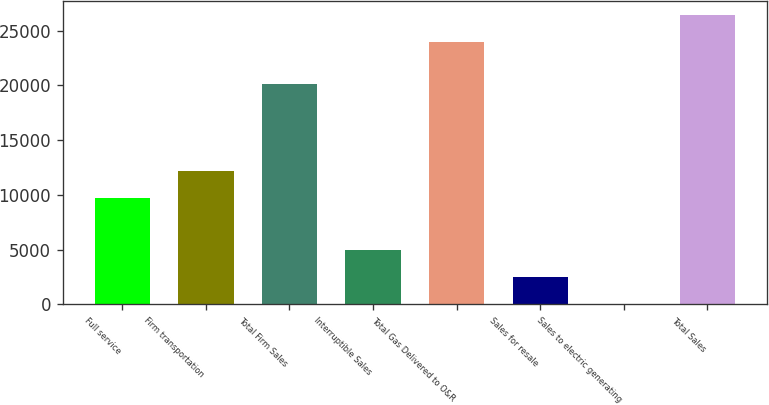Convert chart. <chart><loc_0><loc_0><loc_500><loc_500><bar_chart><fcel>Full service<fcel>Firm transportation<fcel>Total Firm Sales<fcel>Interruptible Sales<fcel>Total Gas Delivered to O&R<fcel>Sales for resale<fcel>Sales to electric generating<fcel>Total Sales<nl><fcel>9723<fcel>12207<fcel>20104<fcel>4986<fcel>23957<fcel>2502<fcel>18<fcel>26441<nl></chart> 